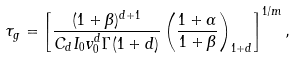<formula> <loc_0><loc_0><loc_500><loc_500>\tau _ { g } = \left [ \frac { ( 1 + \beta ) ^ { d + 1 } } { C _ { d } I _ { 0 } v _ { 0 } ^ { d } \Gamma ( 1 + d ) } \left ( \frac { 1 + \alpha } { 1 + \beta } \right ) _ { 1 + d } \right ] ^ { 1 / m } ,</formula> 